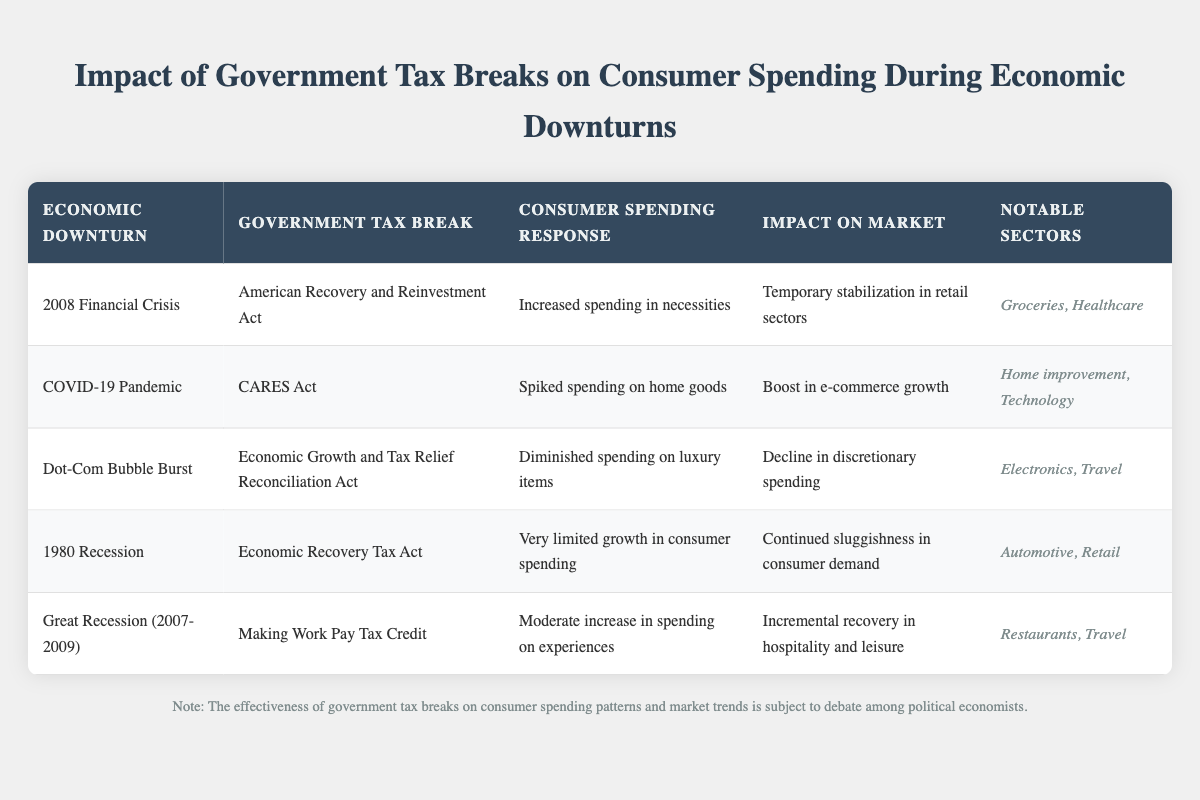What government tax break was implemented during the COVID-19 pandemic? The table indicates that the government tax break during the COVID-19 pandemic was the CARES Act. This information can be found in the row corresponding to the economic downturn labeled "COVID-19 Pandemic."
Answer: CARES Act Which economic downturn is associated with increased spending on necessities? According to the table, the economic downturn associated with increased spending on necessities is the "2008 Financial Crisis." This is detailed in the line that records the consumer spending response for that particular downturn.
Answer: 2008 Financial Crisis Is it true that the American Recovery and Reinvestment Act led to diminished spending on luxury items? The table states that the consumer spending response during the 2008 Financial Crisis was "Increased spending in necessities." Therefore, it does not support the claim regarding diminished spending on luxury items. Consequently, the statement is false.
Answer: No What notable sectors saw a spike in spending during the COVID-19 pandemic? Referring to the respective row for the COVID-19 pandemic, it mentions that the notable sectors with a spike in spending were "Home improvement" and "Technology." This can be gathered from the last column of that row.
Answer: Home improvement, Technology How does the impact on the market for the 1980 recession compare to that of the Great Recession? For the 1980 recession, the impact on the market was "Continued sluggishness in consumer demand," while for the Great Recession, it was "Incremental recovery in hospitality and leisure." The comparison reveals that the Great Recession had a more positive impact on consumer behavior compared to the 1980 recession.
Answer: More positive impact during the Great Recession What was the overall consumer spending response to the Making Work Pay Tax Credit? The table shows that the consumer spending response to the Making Work Pay Tax Credit was a "Moderate increase in spending on experiences." This information can be found in the row pertaining to the Great Recession.
Answer: Moderate increase in spending on experiences During which economic downturn did discretionary spending decline due to tax breaks? The Dot-Com Bubble Burst correlates with the decline in discretionary spending as outlined in the consumer spending response for that downturn labeled as "Diminished spending on luxury items." This is evidenced in the relevant row of the table.
Answer: Dot-Com Bubble Burst Which tax break corresponds to more limited growth in consumer spending during the 1980 recession? According to the table, the tax break corresponding to very limited growth in consumer spending during the 1980 recession is the Economic Recovery Tax Act. This detail is explicitly stated in the corresponding row.
Answer: Economic Recovery Tax Act 